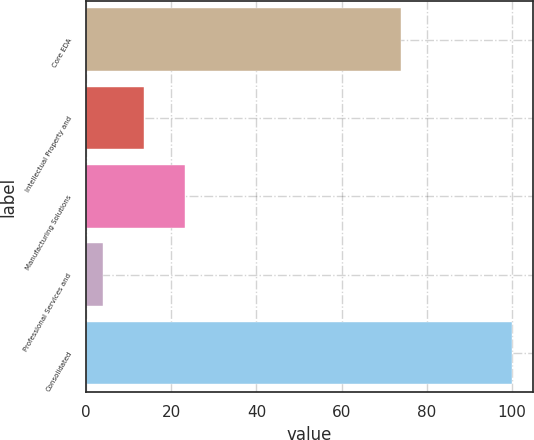<chart> <loc_0><loc_0><loc_500><loc_500><bar_chart><fcel>Core EDA<fcel>Intellectual Property and<fcel>Manufacturing Solutions<fcel>Professional Services and<fcel>Consolidated<nl><fcel>74<fcel>13.6<fcel>23.2<fcel>4<fcel>100<nl></chart> 